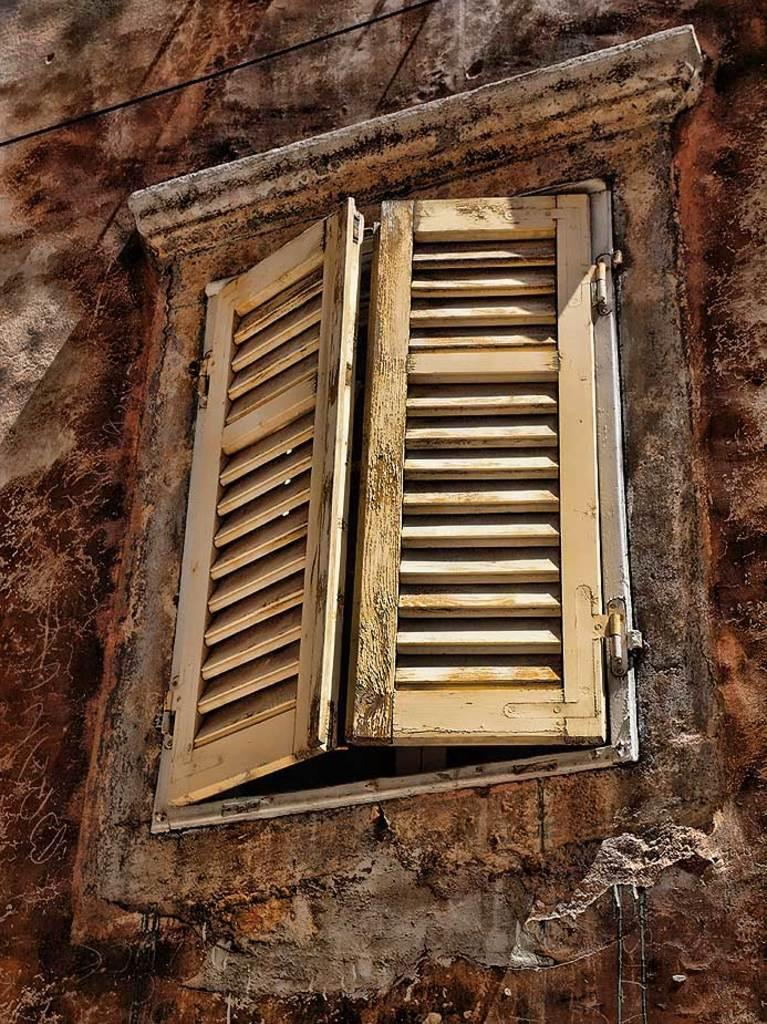What type of opening can be seen in the image? There is a window in the image. What type of structure is present in the image? There is a wall in the image. How many snakes are crawling on the wall in the image? There are no snakes present in the image; it only features a window and a wall. What type of house is depicted in the image? The image does not show a house; it only features a window and a wall. 